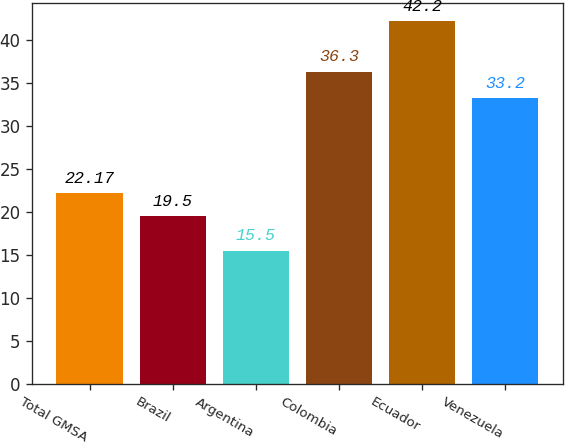Convert chart to OTSL. <chart><loc_0><loc_0><loc_500><loc_500><bar_chart><fcel>Total GMSA<fcel>Brazil<fcel>Argentina<fcel>Colombia<fcel>Ecuador<fcel>Venezuela<nl><fcel>22.17<fcel>19.5<fcel>15.5<fcel>36.3<fcel>42.2<fcel>33.2<nl></chart> 